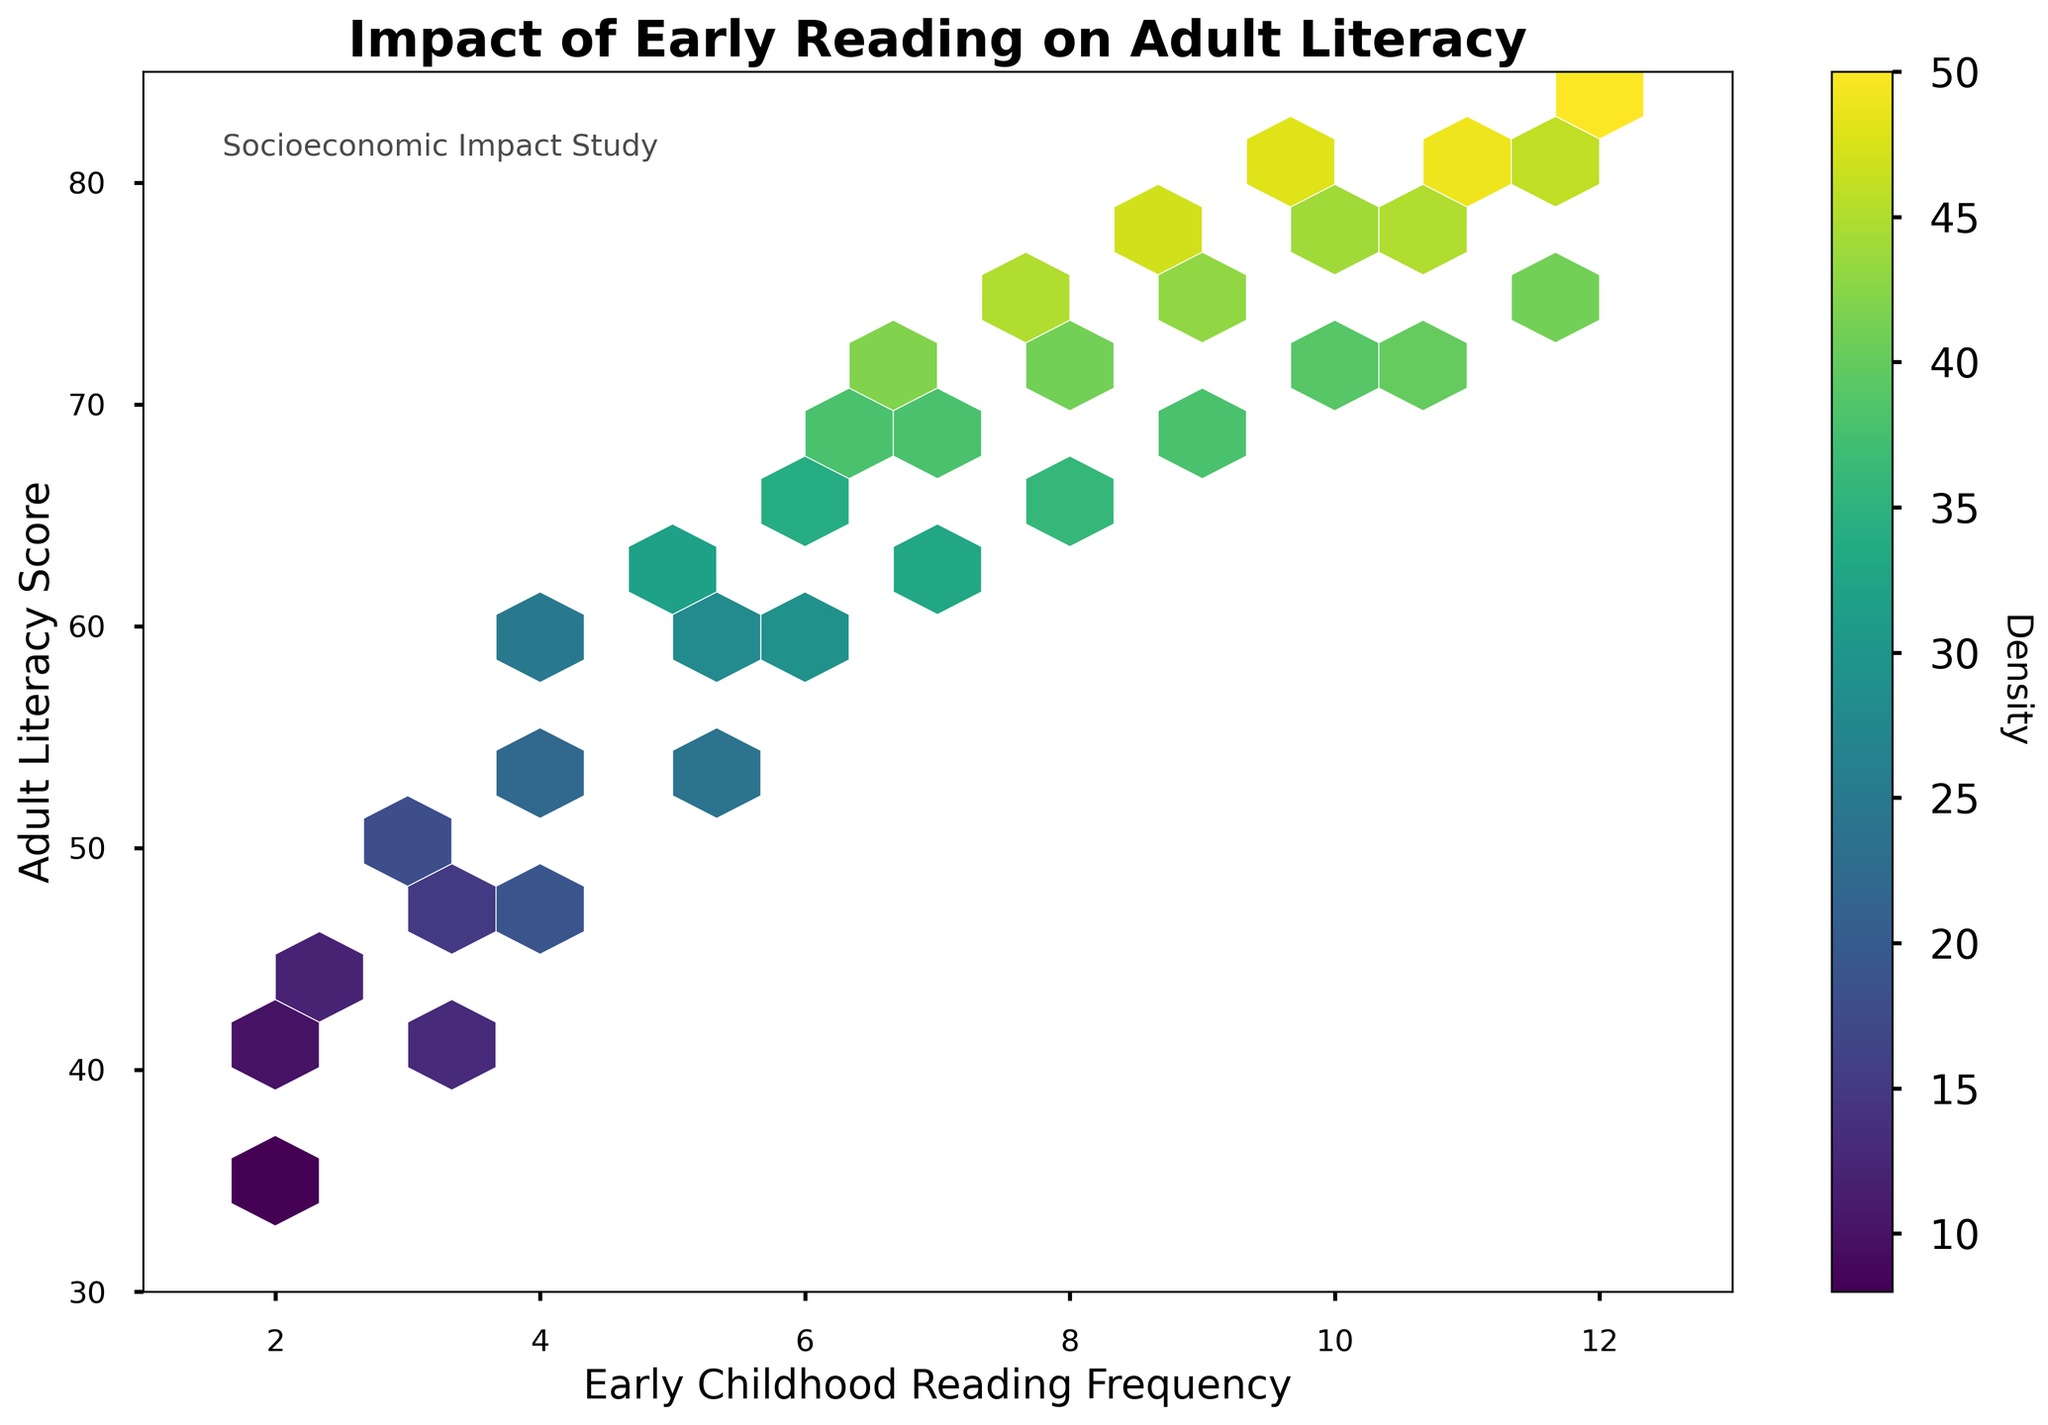What is the title of the hexbin plot? The title is displayed at the top of the plot and is easily readable.
Answer: Impact of Early Reading on Adult Literacy What do the x and y axes represent? The axis labels describe what each axis stands for. The x-axis represents "Early Childhood Reading Frequency," and the y-axis represents "Adult Literacy Score."
Answer: Early Childhood Reading Frequency and Adult Literacy Score In which range do most data points lie for Adult Literacy Score? Analyzing the density shown by different hexbin cells and their color intensity gives the range where most data points lie.
Answer: 50 to 75 What does the color intensity in the hexagons represent? The color bar labeled "Density" next to the plot indicates that the intensity of the color represents the density of data points within each hexagon.
Answer: Density of data points Which early childhood reading frequency is associated with the highest adult literacy score? By looking at hexagons with the highest literacy scores on the y-axis, we see that children with reading frequencies between 11 and 12 have the highest scores.
Answer: 12 In general, what is the trend between early childhood reading frequency and adult literacy score? Observing the scatter pattern and the color density, there appears to be a positive correlation, meaning higher reading frequencies correlate with higher literacy scores.
Answer: Positive correlation Among the socioeconomic groups surveyed, where is the highest density of observations located in terms of reading frequency and literacy score? The densest hexbin, indicated by the darkest color, shows the highest density of observations. This occurs around a reading frequency of 6 to 7, with literacy scores around 68 to 72.
Answer: Reading frequency 6 to 7, literacy scores 68 to 72 What is the range of reading frequencies covered in the plot? The x-axis limits tell us the range of reading frequencies displayed in the plot, which is from 1 to 13.
Answer: 1 to 13 How does the literacy score distribution change with varying reading frequencies? By visually scanning along the y-axis for different slices of the x-axis, we observe that literacy scores generally increase as reading frequency increases, with some fluctuations.
Answer: Increases with some fluctuations What socioeconomic impact was studied according to the text annotation on the plot? The text annotation at the top left part of the plot provides additional context, indicating that a socioeconomic impact study was conducted.
Answer: Socioeconomic Impact Study 